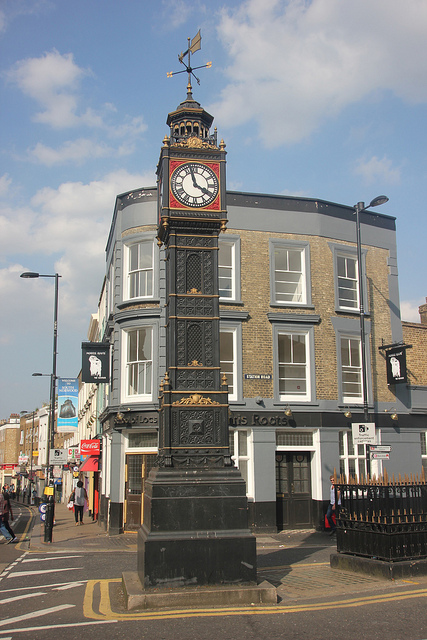Can you describe the architectural style of the buildings in this image? The buildings in this image exhibit a classical architectural style with modern renovations. The presence of large windows, symmetrical design, and brickwork highlights elements common in urban architecture. The clock tower adds a distinct historic charm to the city's streetscape. What purpose might the clock tower serve in this area? The clock tower likely serves as a local landmark and timekeeping structure. It provides a visual focal point, enhancing the area's historical ambiance. Additionally, it might serve practical purposes such as community gatherings or being a point of reference for finding location around the city. 